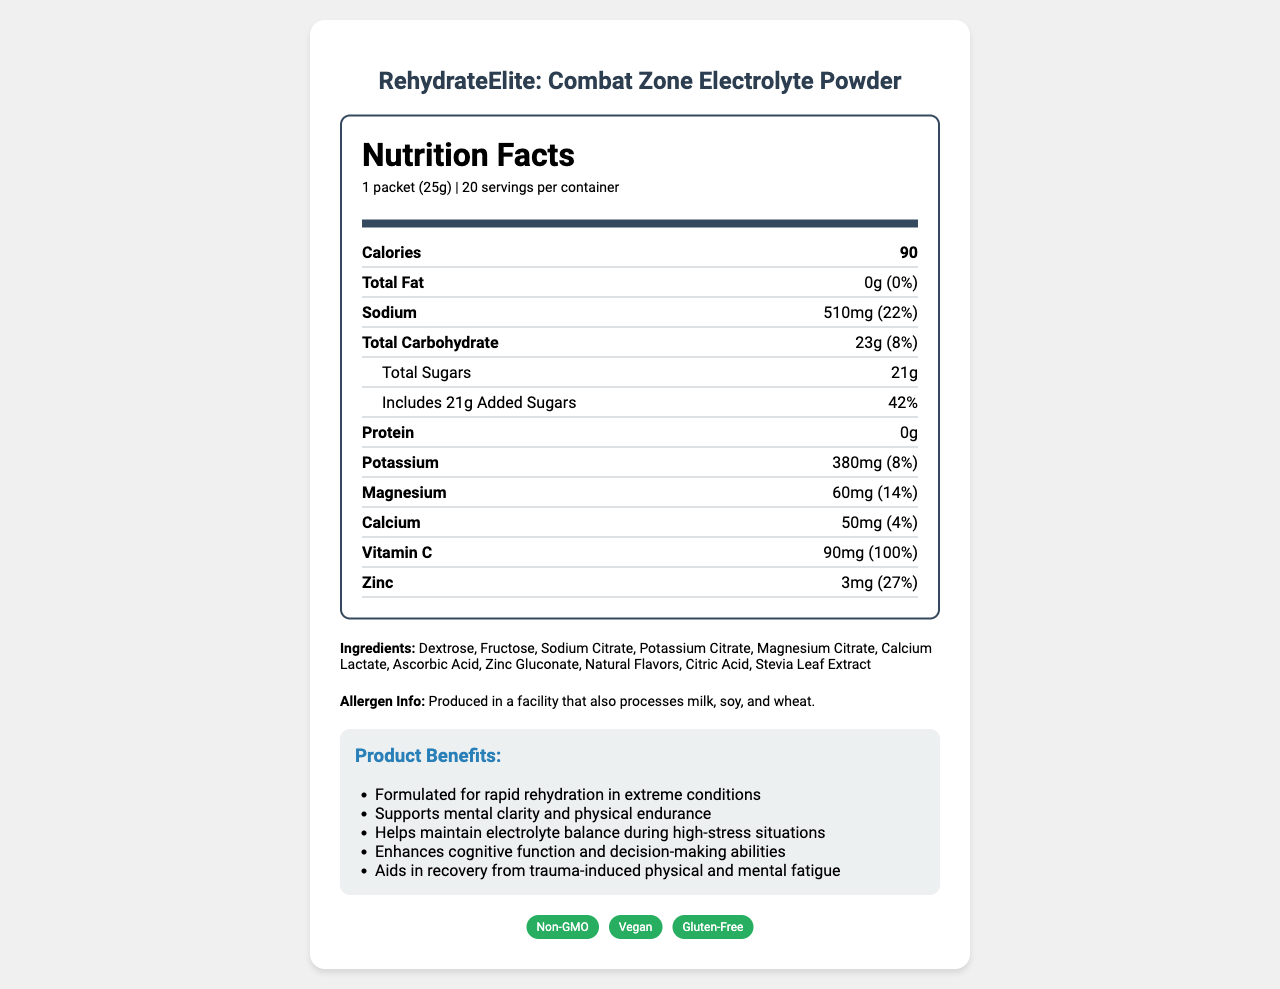what is the serving size? The serving size is specified at the top of the Nutrition Facts section in the document.
Answer: 1 packet (25g) how many calories are in one serving? The calorie content per serving is clearly listed at the top of the Nutrition Facts section.
Answer: 90 how much sodium is in one serving? The sodium content is listed in both milligrams and as a percentage of the daily value.
Answer: 510mg (22%) what is the sugar content per serving, including added sugars? The total sugars section includes 21g of added sugars, which is the entire sugar content for one serving.
Answer: 21g what is the vitamin C content per serving, and how does it compare to daily nutritional needs? The document indicates that one serving provides 90mg of Vitamin C, meeting 100% of the daily value.
Answer: 90mg (100%) what are the main benefits of this product? These benefits are clearly listed under the "Product Benefits" section.
Answer: Formulated for rapid rehydration in extreme conditions, Supports mental clarity and physical endurance, Helps maintain electrolyte balance during high-stress situations, Enhances cognitive function and decision-making abilities, Aids in recovery from trauma-induced physical and mental fatigue what is the flavor of this beverage powder? The flavor is noted in the description of the product packaging.
Answer: Tropical Citrus Burst how many servings are in one container? The servings per container are listed near the top of the Nutrition Facts section.
Answer: 20 what certifications does this product have? The certifications are presented visually with badges at the end of the document.
Answer: Non-GMO, Vegan, Gluten-Free which mineral in the product has the highest daily value percentage? A. Sodium B. Potassium C. Magnesium Sodium has the highest daily value percentage at 22%, compared to Potassium at 8% and Magnesium at 14%.
Answer: A. Sodium how should this product be stored? The storage instructions are specified clearly in the document.
Answer: Store in a cool, dry place. Consume within 2 years of production date. where is this product targeted to be used? The target audience is described near the end of the document.
Answer: Conflict zones for journalists, humanitarian workers, and medical professionals what ingredient is used as a sweetener in the product? Stevia Leaf Extract is listed among the ingredients in the document.
Answer: Stevia Leaf Extract does this product contain any protein? The protein content is listed as 0g (0%) in the Nutrition Facts section.
Answer: No is this product gluten-free? The product has a "Gluten-Free" certification badge.
Answer: Yes does this product contain natural flavors? Natural Flavors are listed as an ingredient in the document.
Answer: Yes what is the main idea of this document? The document details the product's nutritional facts, ingredients, certifications, benefits, and instructions, aimed at individuals in high-stress environments.
Answer: It provides nutritional information, ingredients, certifications, benefits, and usage instructions for "RehydrateElite: Combat Zone Electrolyte Powder". what is the density of the beverage powder in grams per milliliter (g/ml)? The document does not provide the information needed to determine the density, such as the volume or weight per milliliter.
Answer: Not enough information 